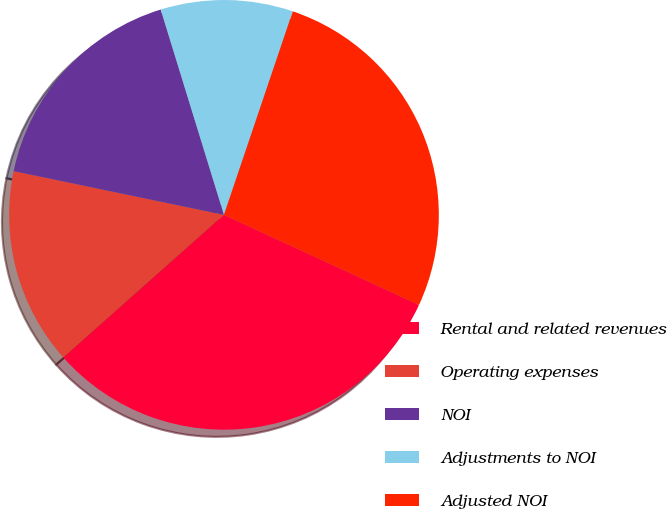<chart> <loc_0><loc_0><loc_500><loc_500><pie_chart><fcel>Rental and related revenues<fcel>Operating expenses<fcel>NOI<fcel>Adjustments to NOI<fcel>Adjusted NOI<nl><fcel>31.56%<fcel>14.82%<fcel>16.98%<fcel>9.95%<fcel>26.69%<nl></chart> 